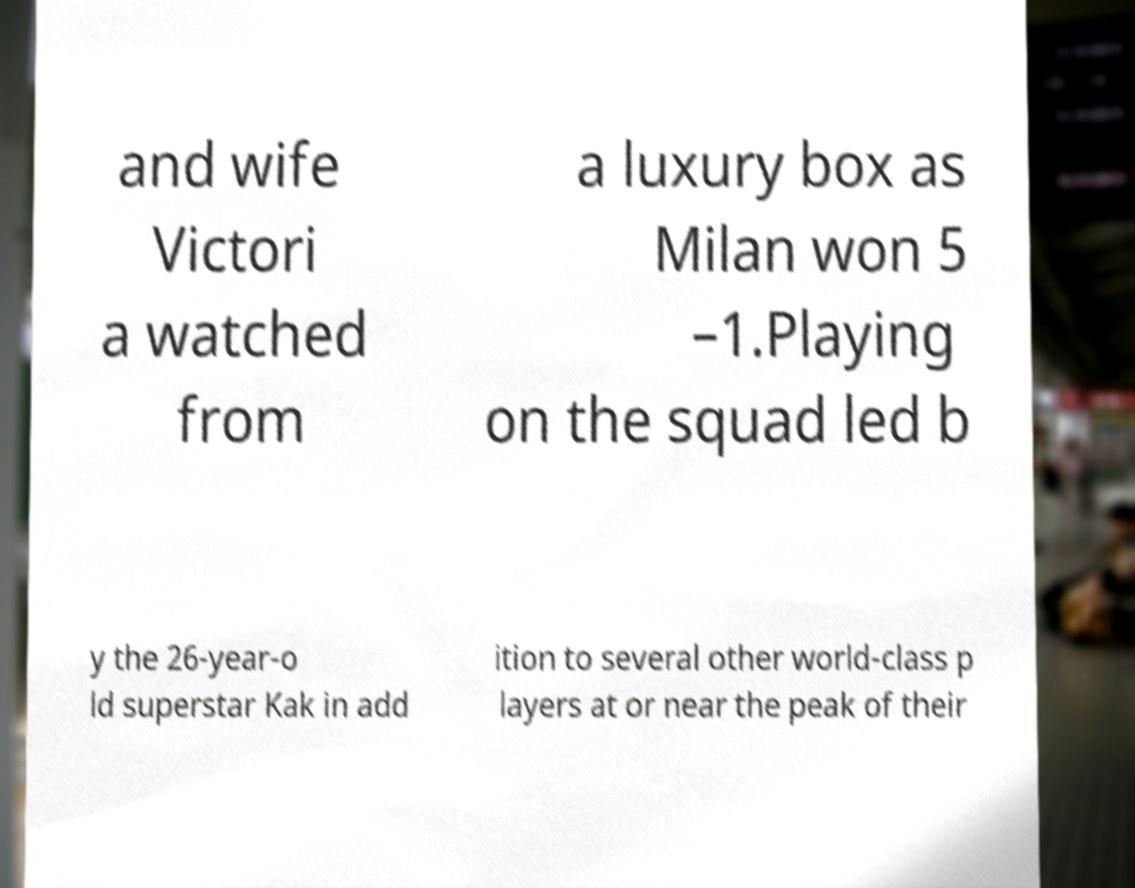Please identify and transcribe the text found in this image. and wife Victori a watched from a luxury box as Milan won 5 –1.Playing on the squad led b y the 26-year-o ld superstar Kak in add ition to several other world-class p layers at or near the peak of their 